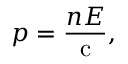Convert formula to latex. <formula><loc_0><loc_0><loc_500><loc_500>p = { \frac { n E } { c } } ,</formula> 